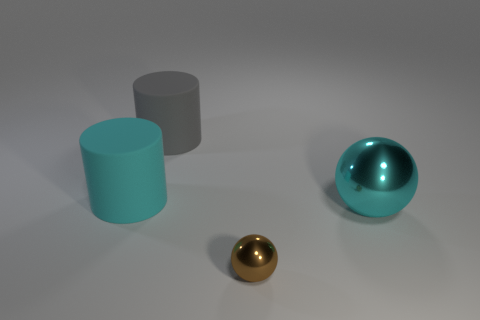Is there a small yellow thing made of the same material as the gray thing?
Your answer should be compact. No. Are there more gray cylinders than big green cylinders?
Provide a short and direct response. Yes. Do the gray cylinder and the large ball have the same material?
Make the answer very short. No. What number of shiny things are small gray cubes or gray cylinders?
Offer a very short reply. 0. There is another metallic object that is the same size as the gray object; what color is it?
Keep it short and to the point. Cyan. What number of large gray things are the same shape as the cyan metallic object?
Your answer should be compact. 0. What number of cylinders are small objects or large gray objects?
Offer a very short reply. 1. There is a big cyan thing that is to the right of the small metallic sphere; is its shape the same as the cyan object that is left of the tiny brown metallic ball?
Offer a terse response. No. What is the gray cylinder made of?
Offer a very short reply. Rubber. There is a rubber thing that is the same color as the large shiny thing; what shape is it?
Keep it short and to the point. Cylinder. 